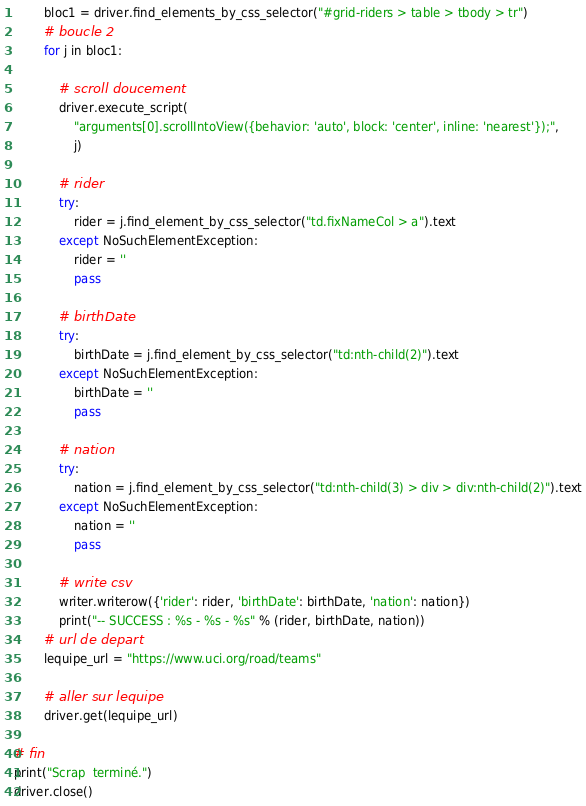Convert code to text. <code><loc_0><loc_0><loc_500><loc_500><_Python_>        bloc1 = driver.find_elements_by_css_selector("#grid-riders > table > tbody > tr")
        # boucle 2
        for j in bloc1:

            # scroll doucement
            driver.execute_script(
                "arguments[0].scrollIntoView({behavior: 'auto', block: 'center', inline: 'nearest'});",
                j)

            # rider
            try:
                rider = j.find_element_by_css_selector("td.fixNameCol > a").text
            except NoSuchElementException:
                rider = ''
                pass

            # birthDate
            try:
                birthDate = j.find_element_by_css_selector("td:nth-child(2)").text
            except NoSuchElementException:
                birthDate = ''
                pass

            # nation
            try:
                nation = j.find_element_by_css_selector("td:nth-child(3) > div > div:nth-child(2)").text
            except NoSuchElementException:
                nation = ''
                pass

            # write csv
            writer.writerow({'rider': rider, 'birthDate': birthDate, 'nation': nation})
            print("-- SUCCESS : %s - %s - %s" % (rider, birthDate, nation))
        # url de depart
        lequipe_url = "https://www.uci.org/road/teams"

        # aller sur lequipe
        driver.get(lequipe_url)

# fin
print("Scrap  terminé.")
driver.close()
</code> 